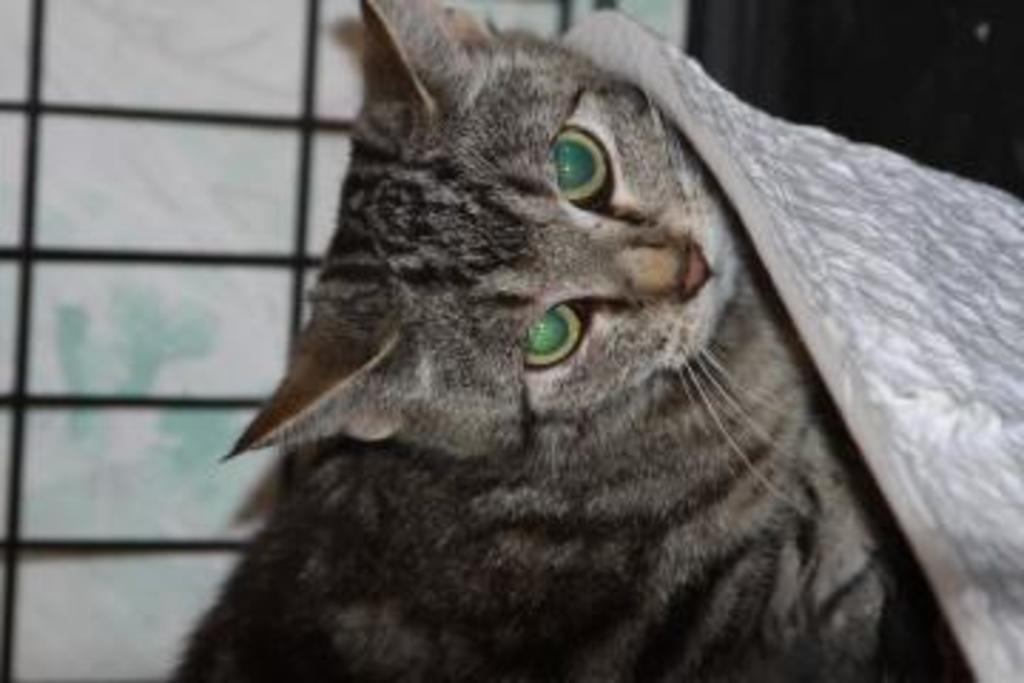What is the main subject of the image? The main subject of the image is a cat. Can you describe the background of the image? The background of the image is blurry. Is there any other element visible in the image besides the cat? Yes, there is a window behind the cat. What type of stem can be seen growing from the cat's ear in the image? There is no stem growing from the cat's ear in the image; it is a picture of a cat with a blurry background and a window behind it. 